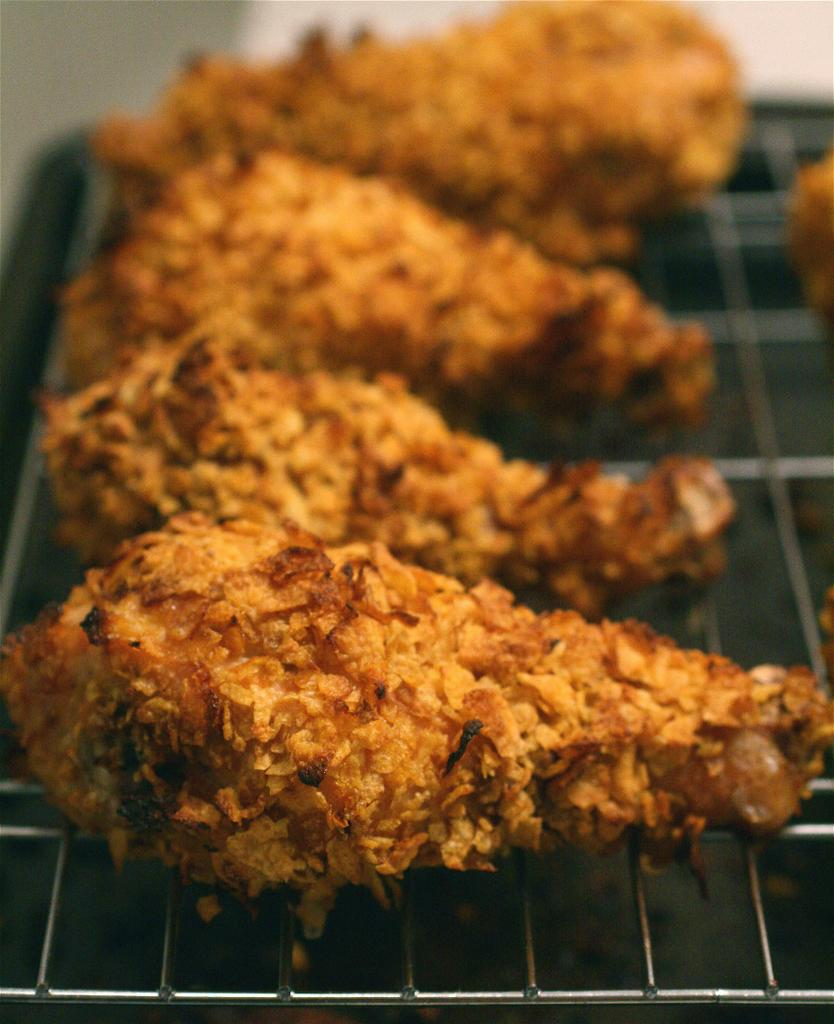What is happening to the food items in the image? The food items are on a grille in the image. Can you describe the background of the image? The background of the image is blurred. What type of arithmetic problem can be solved using the toes in the image? There are no toes present in the image, and therefore no arithmetic problem can be solved using them. 